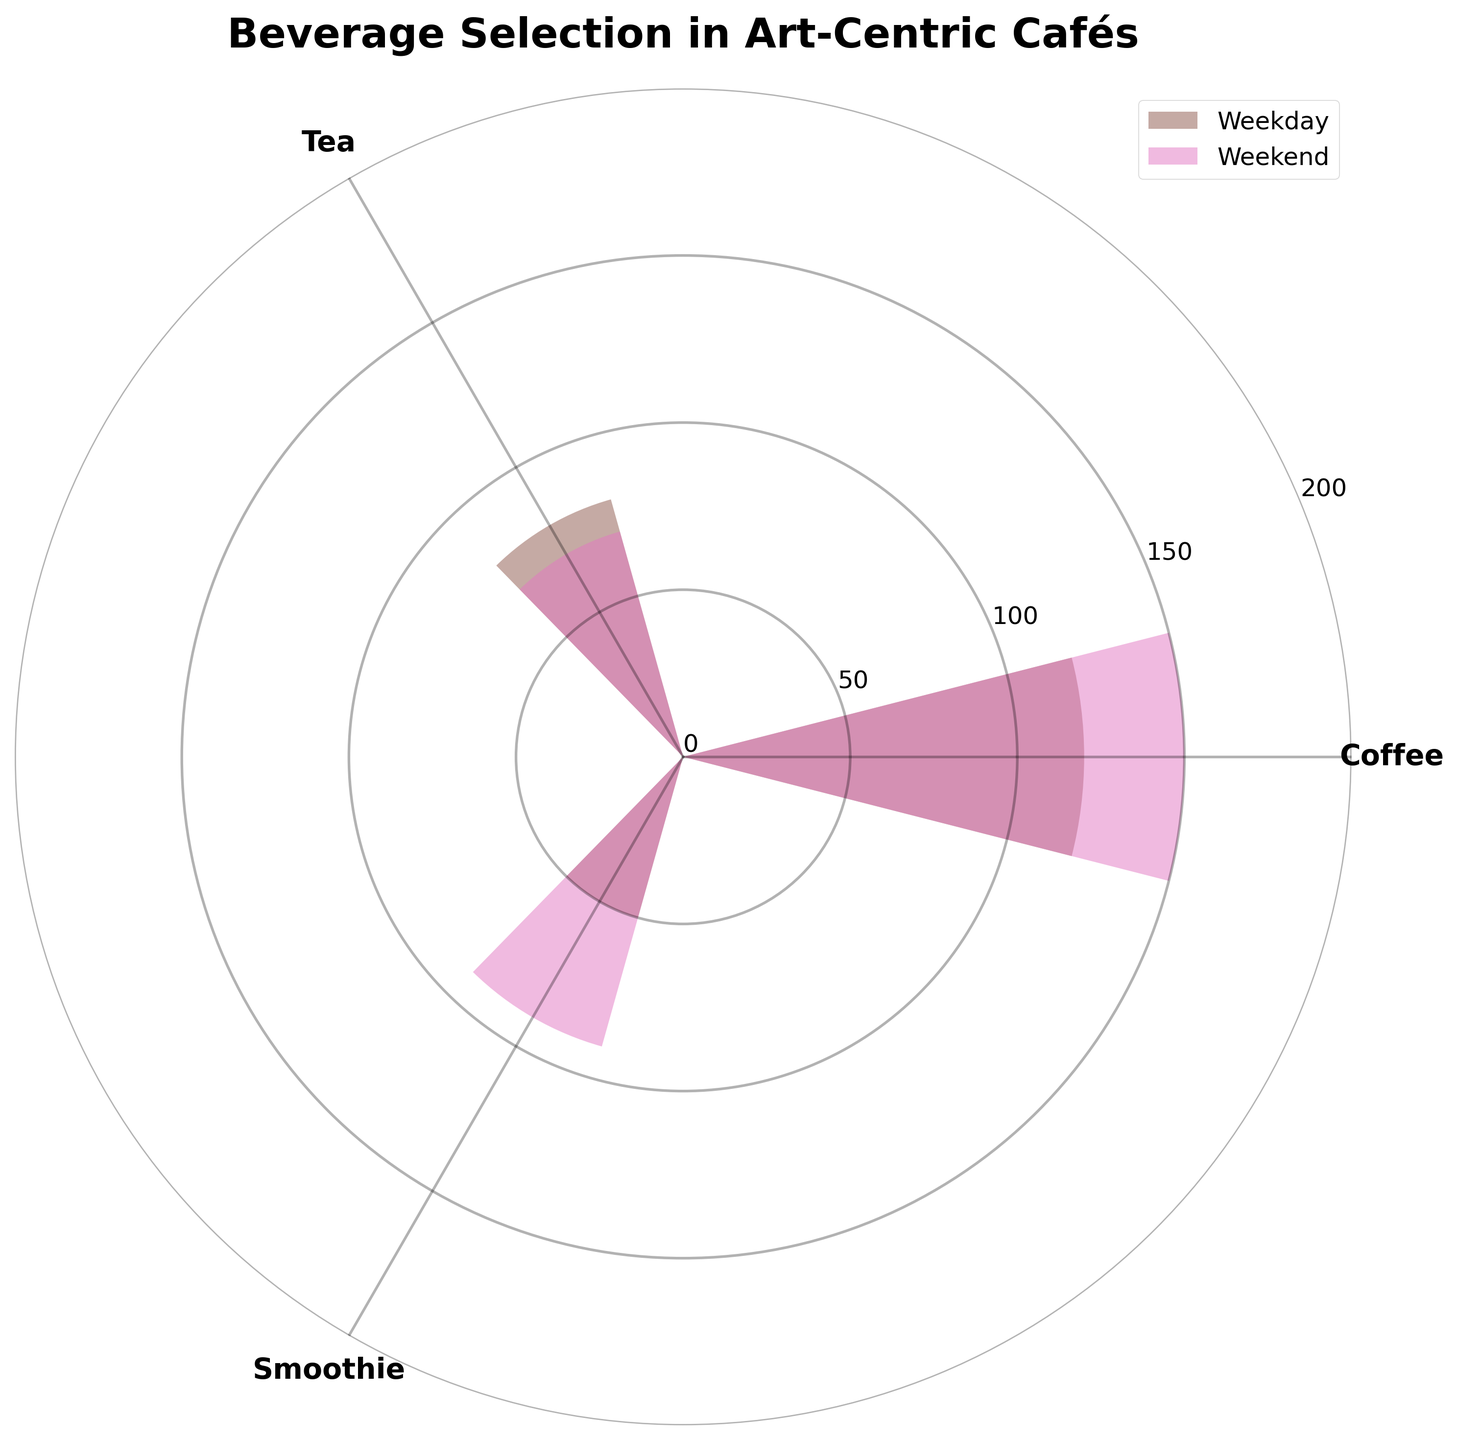What is the title of the chart? The title is typically placed at the top of the chart. In this figure, it reads "Beverage Selection in Art-Centric Cafés".
Answer: Beverage Selection in Art-Centric Cafés Which beverage has the highest frequency on weekends? By looking at the bar heights labeled for "Weekend", we can see that "Coffee" has the tallest bar.
Answer: Coffee How many beverages are compared in the chart? The x-ticks represent different beverages, and there are three labels: Coffee, Tea, and Smoothie.
Answer: Three Which beverage has a decrease in frequency from weekdays to weekends? By comparing the heights of the bars for each beverage, we can see that "Tea" is the only one with a shorter height on weekends than on weekdays.
Answer: Tea What is the total selection frequency for smoothies across both weekdays and weekends? To get the total, we add the weekday value (50) to the weekend value (90), resulting in 140.
Answer: 140 Which day has a higher overall selection frequency for beverages, weekdays or weekends? We need to sum the frequencies for each day:
Weekdays: 120 (Coffee) + 80 (Tea) + 50 (Smoothie) = 250
Weekends: 150 (Coffee) + 70 (Tea) + 90 (Smoothie) = 310
Since 310 > 250, weekends have the higher overall frequency.
Answer: Weekends What is the difference in coffee selection frequency between weekdays and weekends? Subtract the weekday value for coffee from the weekend value: 150 - 120 = 30.
Answer: 30 How does the selection frequency of tea compare to that of smoothies on weekends? By comparing the bar heights, the tea frequency is 70, and the smoothie frequency is 90. Since 70 is less than 90, smoothies are more popular on weekends.
Answer: Smoothies are more popular Among the three beverages, which one is selected the least on weekdays? By observing the lowest bar height labeled for "Weekday", smoothies have the smallest value at 50.
Answer: Smoothies What is the average selection frequency of coffee across weekdays and weekends? Add the weekday and weekend values for coffee (120 + 150 = 270), then divide by 2, resulting in an average of 135.
Answer: 135 